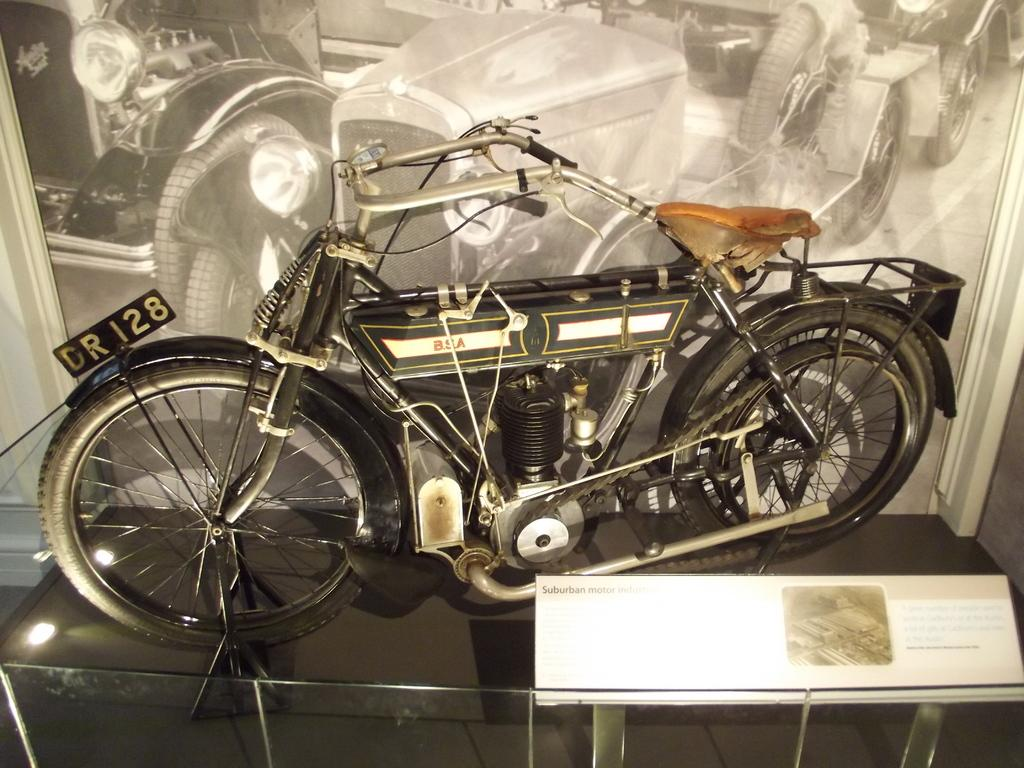What object is placed on the floor in the image? There is a bike on the floor in the image. What other objects can be seen in the image? There is a board, a glass object, and a photo frame in the image. Can you describe the setting where the image might have been taken? The image may have been taken in a hall. What type of bear can be seen interacting with the bike in the image? There is no bear present in the image; it only features a bike, a board, a glass object, and a photo frame. Can you provide an example of a similar image with a bear? Since there is no bear in the provided image, it is not possible to provide an example of a similar image with a bear. 